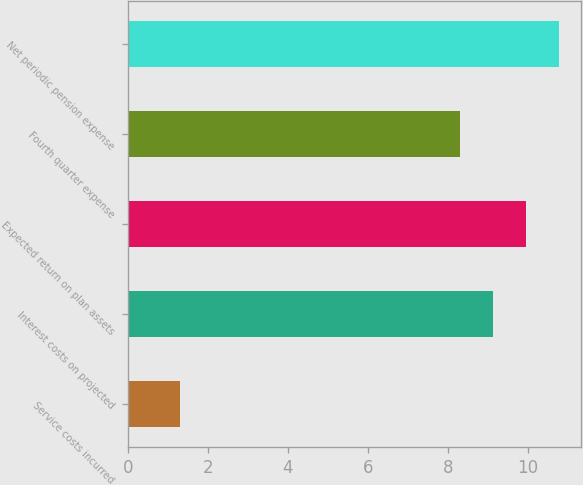<chart> <loc_0><loc_0><loc_500><loc_500><bar_chart><fcel>Service costs incurred<fcel>Interest costs on projected<fcel>Expected return on plan assets<fcel>Fourth quarter expense<fcel>Net periodic pension expense<nl><fcel>1.3<fcel>9.13<fcel>9.96<fcel>8.3<fcel>10.79<nl></chart> 